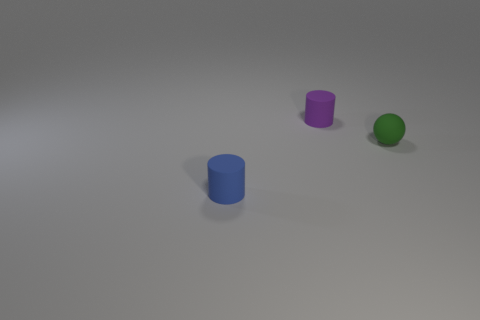Add 2 small brown matte balls. How many objects exist? 5 Subtract all balls. How many objects are left? 2 Subtract 0 red cylinders. How many objects are left? 3 Subtract all large blue shiny cubes. Subtract all purple objects. How many objects are left? 2 Add 2 rubber cylinders. How many rubber cylinders are left? 4 Add 3 blue rubber cylinders. How many blue rubber cylinders exist? 4 